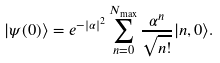<formula> <loc_0><loc_0><loc_500><loc_500>| \psi ( 0 ) \rangle = e ^ { - | \alpha | ^ { 2 } } \sum _ { n = 0 } ^ { N _ { \max } } \frac { \alpha ^ { n } } { \sqrt { n ! } } | n , 0 \rangle .</formula> 